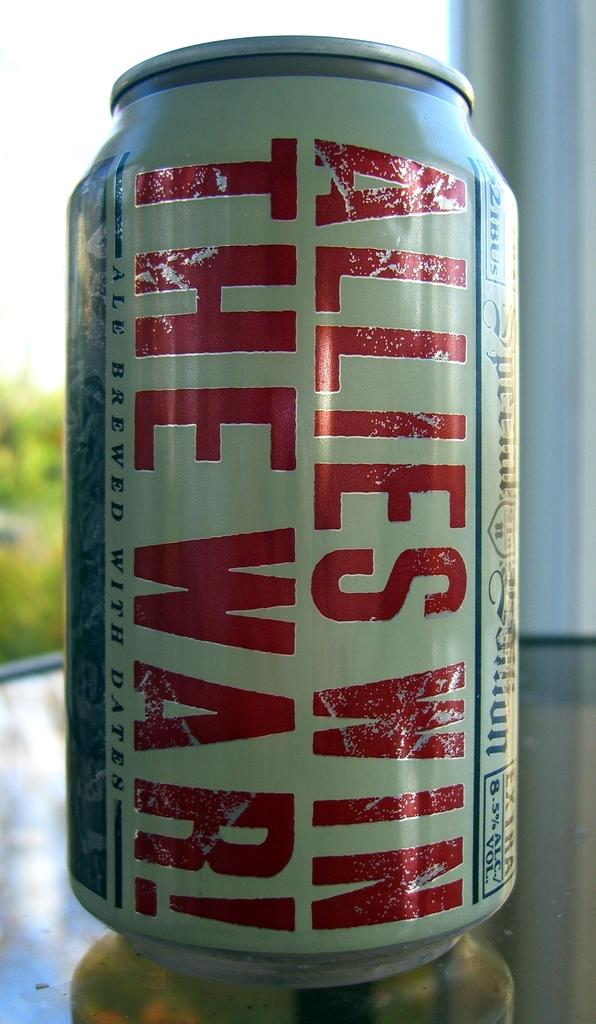<image>
Create a compact narrative representing the image presented. Bottle of ale that says "Allies Win The War!" on the front. 